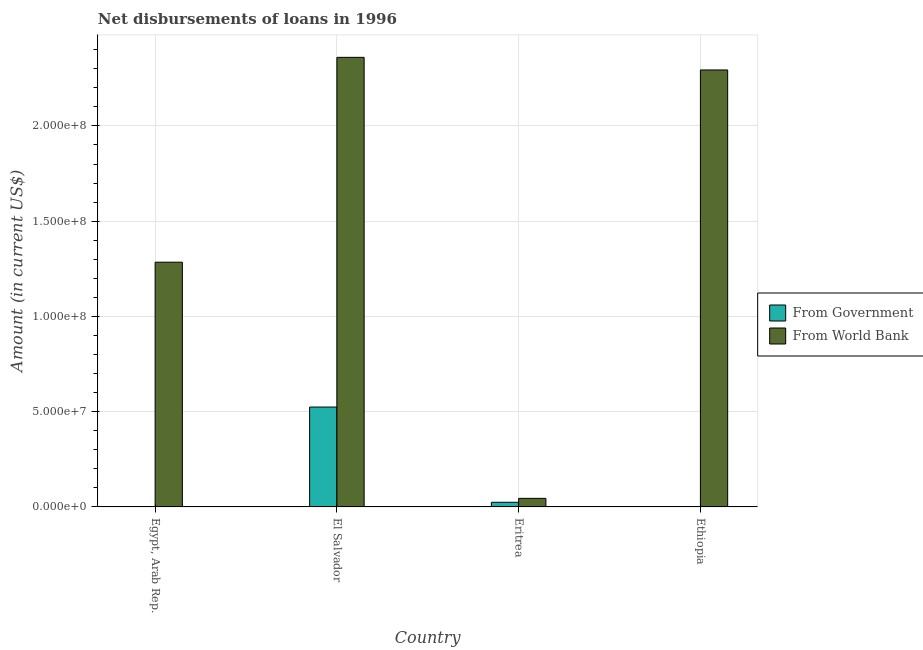Are the number of bars per tick equal to the number of legend labels?
Make the answer very short. No. How many bars are there on the 1st tick from the right?
Provide a short and direct response. 1. What is the label of the 2nd group of bars from the left?
Your answer should be very brief. El Salvador. Across all countries, what is the maximum net disbursements of loan from world bank?
Provide a succinct answer. 2.36e+08. Across all countries, what is the minimum net disbursements of loan from world bank?
Ensure brevity in your answer.  4.49e+06. In which country was the net disbursements of loan from government maximum?
Make the answer very short. El Salvador. What is the total net disbursements of loan from government in the graph?
Ensure brevity in your answer.  5.49e+07. What is the difference between the net disbursements of loan from world bank in El Salvador and that in Eritrea?
Ensure brevity in your answer.  2.32e+08. What is the difference between the net disbursements of loan from government in Ethiopia and the net disbursements of loan from world bank in Eritrea?
Give a very brief answer. -4.49e+06. What is the average net disbursements of loan from government per country?
Your answer should be very brief. 1.37e+07. What is the difference between the net disbursements of loan from world bank and net disbursements of loan from government in El Salvador?
Make the answer very short. 1.84e+08. In how many countries, is the net disbursements of loan from world bank greater than 210000000 US$?
Offer a terse response. 2. What is the ratio of the net disbursements of loan from world bank in Egypt, Arab Rep. to that in Ethiopia?
Keep it short and to the point. 0.56. Is the difference between the net disbursements of loan from government in El Salvador and Eritrea greater than the difference between the net disbursements of loan from world bank in El Salvador and Eritrea?
Provide a succinct answer. No. What is the difference between the highest and the lowest net disbursements of loan from world bank?
Keep it short and to the point. 2.32e+08. In how many countries, is the net disbursements of loan from world bank greater than the average net disbursements of loan from world bank taken over all countries?
Give a very brief answer. 2. Is the sum of the net disbursements of loan from world bank in El Salvador and Ethiopia greater than the maximum net disbursements of loan from government across all countries?
Make the answer very short. Yes. Are all the bars in the graph horizontal?
Provide a short and direct response. No. What is the difference between two consecutive major ticks on the Y-axis?
Your answer should be very brief. 5.00e+07. How many legend labels are there?
Provide a succinct answer. 2. What is the title of the graph?
Provide a short and direct response. Net disbursements of loans in 1996. What is the label or title of the X-axis?
Give a very brief answer. Country. What is the Amount (in current US$) in From Government in Egypt, Arab Rep.?
Offer a very short reply. 0. What is the Amount (in current US$) of From World Bank in Egypt, Arab Rep.?
Give a very brief answer. 1.28e+08. What is the Amount (in current US$) in From Government in El Salvador?
Keep it short and to the point. 5.24e+07. What is the Amount (in current US$) of From World Bank in El Salvador?
Offer a terse response. 2.36e+08. What is the Amount (in current US$) of From Government in Eritrea?
Your answer should be compact. 2.44e+06. What is the Amount (in current US$) of From World Bank in Eritrea?
Your answer should be very brief. 4.49e+06. What is the Amount (in current US$) in From Government in Ethiopia?
Give a very brief answer. 0. What is the Amount (in current US$) in From World Bank in Ethiopia?
Offer a very short reply. 2.29e+08. Across all countries, what is the maximum Amount (in current US$) of From Government?
Provide a short and direct response. 5.24e+07. Across all countries, what is the maximum Amount (in current US$) of From World Bank?
Your answer should be very brief. 2.36e+08. Across all countries, what is the minimum Amount (in current US$) of From Government?
Offer a terse response. 0. Across all countries, what is the minimum Amount (in current US$) in From World Bank?
Your answer should be compact. 4.49e+06. What is the total Amount (in current US$) in From Government in the graph?
Provide a short and direct response. 5.49e+07. What is the total Amount (in current US$) in From World Bank in the graph?
Make the answer very short. 5.98e+08. What is the difference between the Amount (in current US$) of From World Bank in Egypt, Arab Rep. and that in El Salvador?
Keep it short and to the point. -1.08e+08. What is the difference between the Amount (in current US$) in From World Bank in Egypt, Arab Rep. and that in Eritrea?
Ensure brevity in your answer.  1.24e+08. What is the difference between the Amount (in current US$) in From World Bank in Egypt, Arab Rep. and that in Ethiopia?
Your answer should be compact. -1.01e+08. What is the difference between the Amount (in current US$) in From Government in El Salvador and that in Eritrea?
Your response must be concise. 5.00e+07. What is the difference between the Amount (in current US$) of From World Bank in El Salvador and that in Eritrea?
Keep it short and to the point. 2.32e+08. What is the difference between the Amount (in current US$) of From World Bank in El Salvador and that in Ethiopia?
Your response must be concise. 6.62e+06. What is the difference between the Amount (in current US$) of From World Bank in Eritrea and that in Ethiopia?
Offer a terse response. -2.25e+08. What is the difference between the Amount (in current US$) in From Government in El Salvador and the Amount (in current US$) in From World Bank in Eritrea?
Keep it short and to the point. 4.79e+07. What is the difference between the Amount (in current US$) in From Government in El Salvador and the Amount (in current US$) in From World Bank in Ethiopia?
Your answer should be very brief. -1.77e+08. What is the difference between the Amount (in current US$) in From Government in Eritrea and the Amount (in current US$) in From World Bank in Ethiopia?
Make the answer very short. -2.27e+08. What is the average Amount (in current US$) of From Government per country?
Keep it short and to the point. 1.37e+07. What is the average Amount (in current US$) of From World Bank per country?
Provide a succinct answer. 1.50e+08. What is the difference between the Amount (in current US$) in From Government and Amount (in current US$) in From World Bank in El Salvador?
Your answer should be very brief. -1.84e+08. What is the difference between the Amount (in current US$) of From Government and Amount (in current US$) of From World Bank in Eritrea?
Give a very brief answer. -2.06e+06. What is the ratio of the Amount (in current US$) in From World Bank in Egypt, Arab Rep. to that in El Salvador?
Ensure brevity in your answer.  0.54. What is the ratio of the Amount (in current US$) of From World Bank in Egypt, Arab Rep. to that in Eritrea?
Your answer should be compact. 28.59. What is the ratio of the Amount (in current US$) in From World Bank in Egypt, Arab Rep. to that in Ethiopia?
Keep it short and to the point. 0.56. What is the ratio of the Amount (in current US$) of From Government in El Salvador to that in Eritrea?
Your answer should be very brief. 21.5. What is the ratio of the Amount (in current US$) of From World Bank in El Salvador to that in Eritrea?
Ensure brevity in your answer.  52.53. What is the ratio of the Amount (in current US$) in From World Bank in El Salvador to that in Ethiopia?
Give a very brief answer. 1.03. What is the ratio of the Amount (in current US$) of From World Bank in Eritrea to that in Ethiopia?
Offer a very short reply. 0.02. What is the difference between the highest and the second highest Amount (in current US$) in From World Bank?
Give a very brief answer. 6.62e+06. What is the difference between the highest and the lowest Amount (in current US$) in From Government?
Your answer should be very brief. 5.24e+07. What is the difference between the highest and the lowest Amount (in current US$) of From World Bank?
Provide a short and direct response. 2.32e+08. 